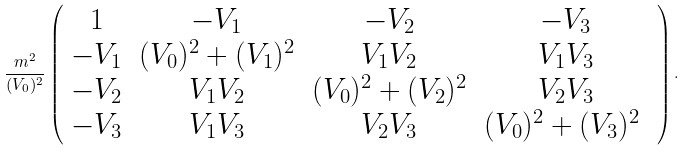<formula> <loc_0><loc_0><loc_500><loc_500>\frac { m ^ { 2 } } { ( V _ { 0 } ) ^ { 2 } } \left ( \begin{array} { c c c c } 1 & - V _ { 1 } & - V _ { 2 } & - V _ { 3 } \\ - V _ { 1 } & ( V _ { 0 } ) ^ { 2 } + ( V _ { 1 } ) ^ { 2 } & V _ { 1 } V _ { 2 } & V _ { 1 } V _ { 3 } \\ - V _ { 2 } & V _ { 1 } V _ { 2 } & ( V _ { 0 } ) ^ { 2 } + ( V _ { 2 } ) ^ { 2 } & V _ { 2 } V _ { 3 } \\ - V _ { 3 } & V _ { 1 } V _ { 3 } & V _ { 2 } V _ { 3 } & ( V _ { 0 } ) ^ { 2 } + ( V _ { 3 } ) ^ { 2 } \ \end{array} \right ) .</formula> 